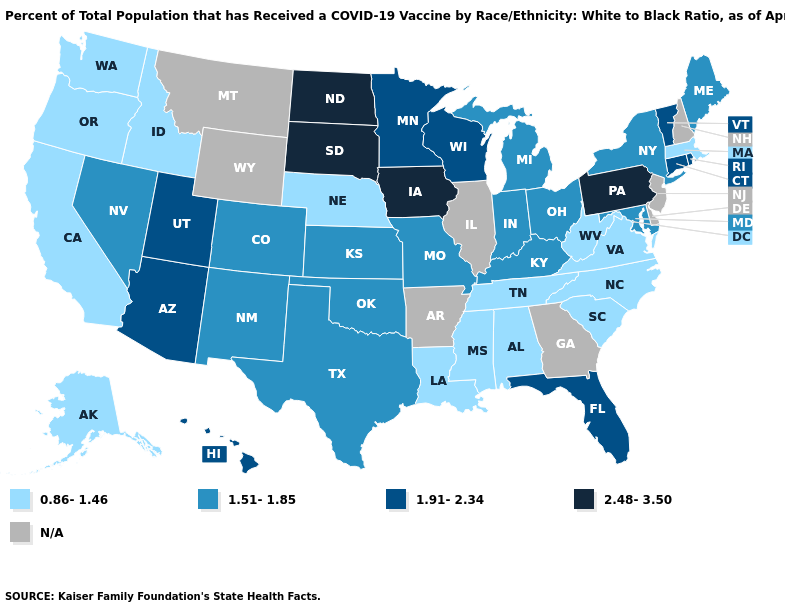Among the states that border Nevada , does Utah have the highest value?
Give a very brief answer. Yes. Does Nebraska have the lowest value in the MidWest?
Short answer required. Yes. Does Colorado have the highest value in the West?
Be succinct. No. Does Ohio have the highest value in the USA?
Answer briefly. No. Name the states that have a value in the range 1.51-1.85?
Short answer required. Colorado, Indiana, Kansas, Kentucky, Maine, Maryland, Michigan, Missouri, Nevada, New Mexico, New York, Ohio, Oklahoma, Texas. Which states hav the highest value in the MidWest?
Short answer required. Iowa, North Dakota, South Dakota. Does Maine have the highest value in the USA?
Give a very brief answer. No. Does the first symbol in the legend represent the smallest category?
Quick response, please. Yes. How many symbols are there in the legend?
Concise answer only. 5. Name the states that have a value in the range 1.51-1.85?
Write a very short answer. Colorado, Indiana, Kansas, Kentucky, Maine, Maryland, Michigan, Missouri, Nevada, New Mexico, New York, Ohio, Oklahoma, Texas. What is the value of Mississippi?
Concise answer only. 0.86-1.46. Among the states that border Nebraska , does South Dakota have the lowest value?
Short answer required. No. What is the lowest value in states that border Florida?
Quick response, please. 0.86-1.46. What is the highest value in the USA?
Quick response, please. 2.48-3.50. 